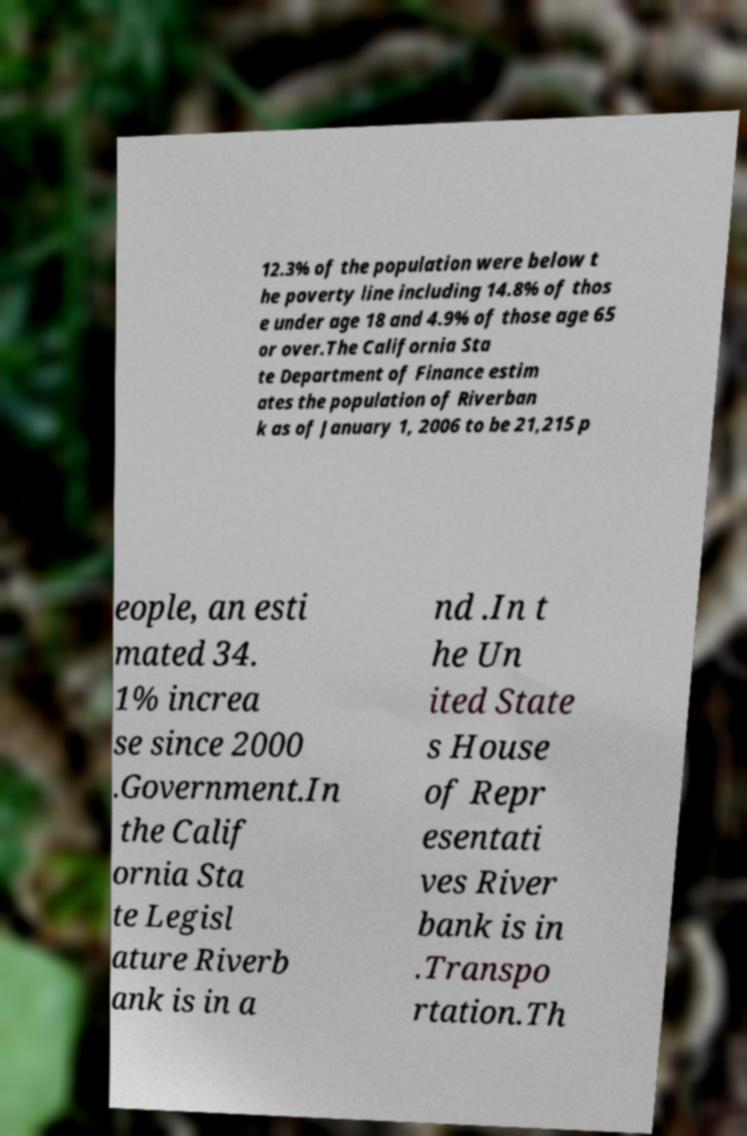What messages or text are displayed in this image? I need them in a readable, typed format. 12.3% of the population were below t he poverty line including 14.8% of thos e under age 18 and 4.9% of those age 65 or over.The California Sta te Department of Finance estim ates the population of Riverban k as of January 1, 2006 to be 21,215 p eople, an esti mated 34. 1% increa se since 2000 .Government.In the Calif ornia Sta te Legisl ature Riverb ank is in a nd .In t he Un ited State s House of Repr esentati ves River bank is in .Transpo rtation.Th 